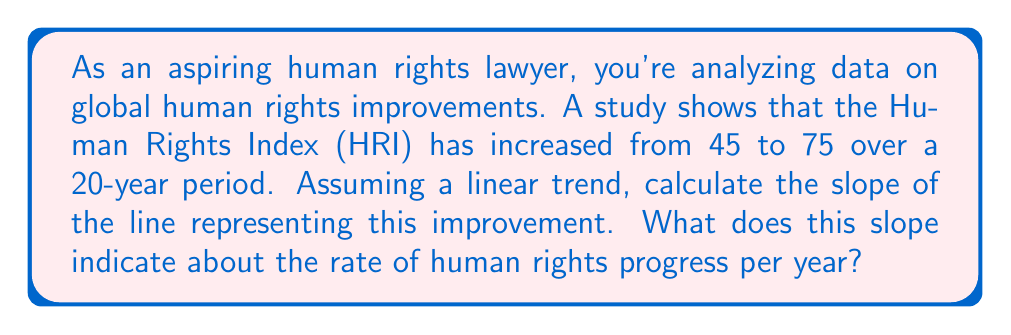Give your solution to this math problem. To solve this problem, we need to use the slope formula:

$$ m = \frac{y_2 - y_1}{x_2 - x_1} $$

Where:
- $m$ is the slope
- $(x_1, y_1)$ is the initial point
- $(x_2, y_2)$ is the final point

Let's identify our points:
- Initial point: $(0, 45)$ (year 0, HRI = 45)
- Final point: $(20, 75)$ (year 20, HRI = 75)

Now, let's plug these values into the slope formula:

$$ m = \frac{75 - 45}{20 - 0} = \frac{30}{20} = 1.5 $$

The slope is 1.5, which means the Human Rights Index increases by 1.5 units per year on average.

To interpret this in the context of human rights:
The positive slope indicates that human rights are improving over time. Specifically, the Human Rights Index is increasing by 1.5 units per year on average, suggesting a steady and significant improvement in global human rights conditions over the 20-year period.
Answer: The slope of the line is 1.5, indicating that the Human Rights Index increases by an average of 1.5 units per year. 